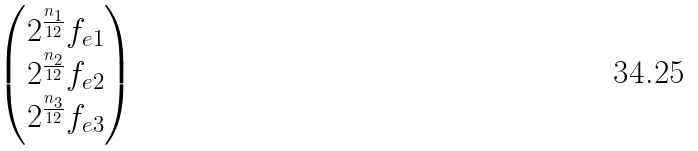<formula> <loc_0><loc_0><loc_500><loc_500>\begin{pmatrix} 2 ^ { \frac { n _ { 1 } } { 1 2 } } f _ { e 1 } \\ 2 ^ { \frac { n _ { 2 } } { 1 2 } } f _ { e 2 } \\ 2 ^ { \frac { n _ { 3 } } { 1 2 } } f _ { e 3 } \\ \end{pmatrix}</formula> 